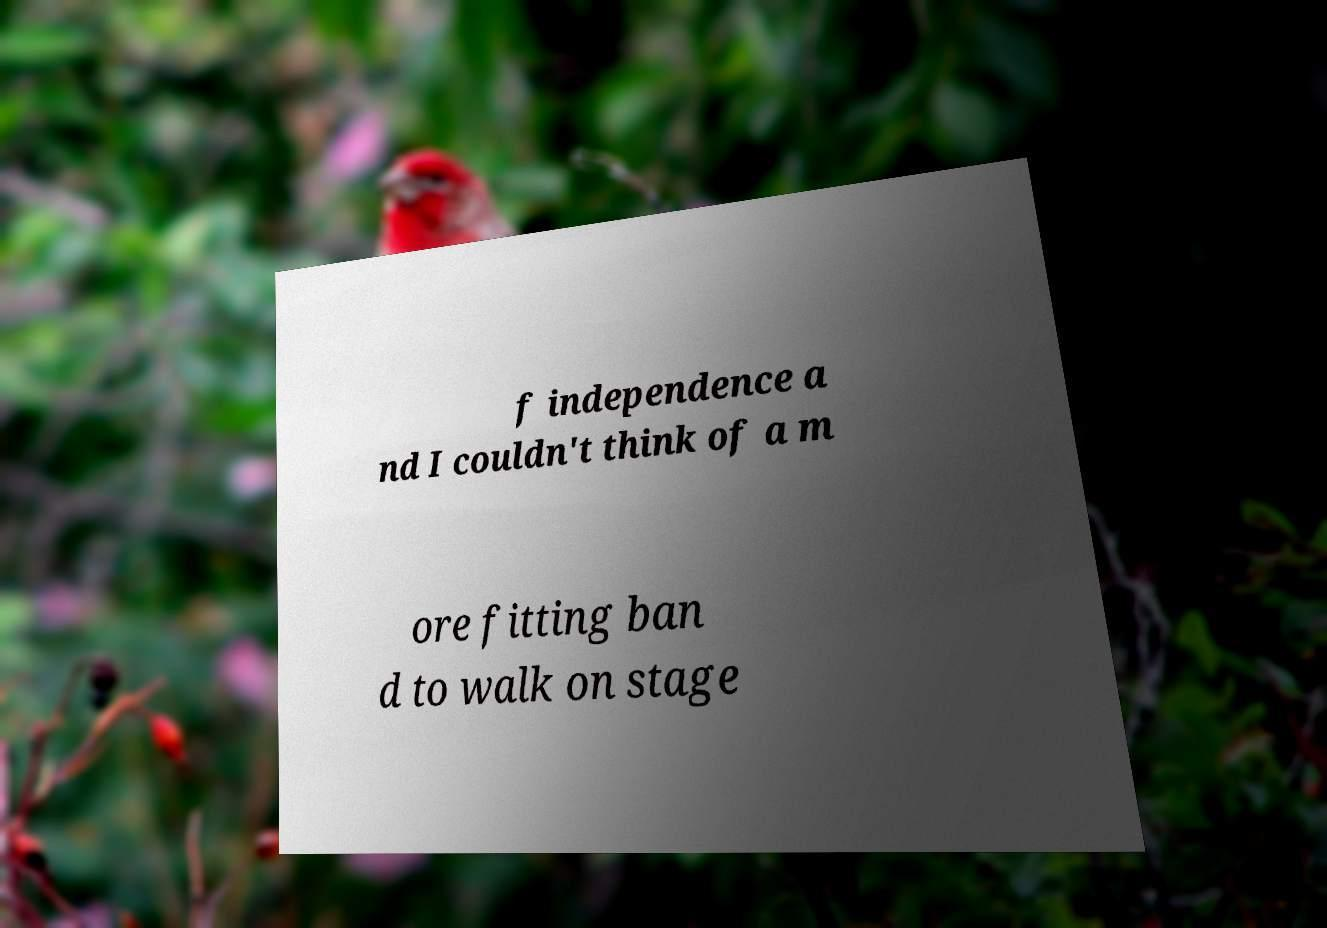There's text embedded in this image that I need extracted. Can you transcribe it verbatim? f independence a nd I couldn't think of a m ore fitting ban d to walk on stage 